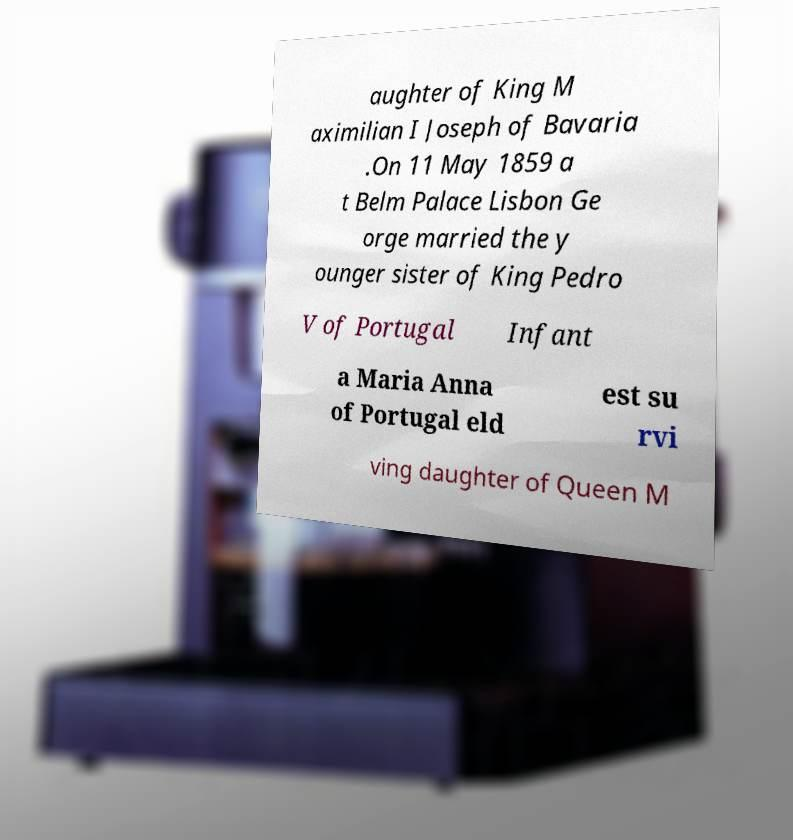Could you extract and type out the text from this image? aughter of King M aximilian I Joseph of Bavaria .On 11 May 1859 a t Belm Palace Lisbon Ge orge married the y ounger sister of King Pedro V of Portugal Infant a Maria Anna of Portugal eld est su rvi ving daughter of Queen M 